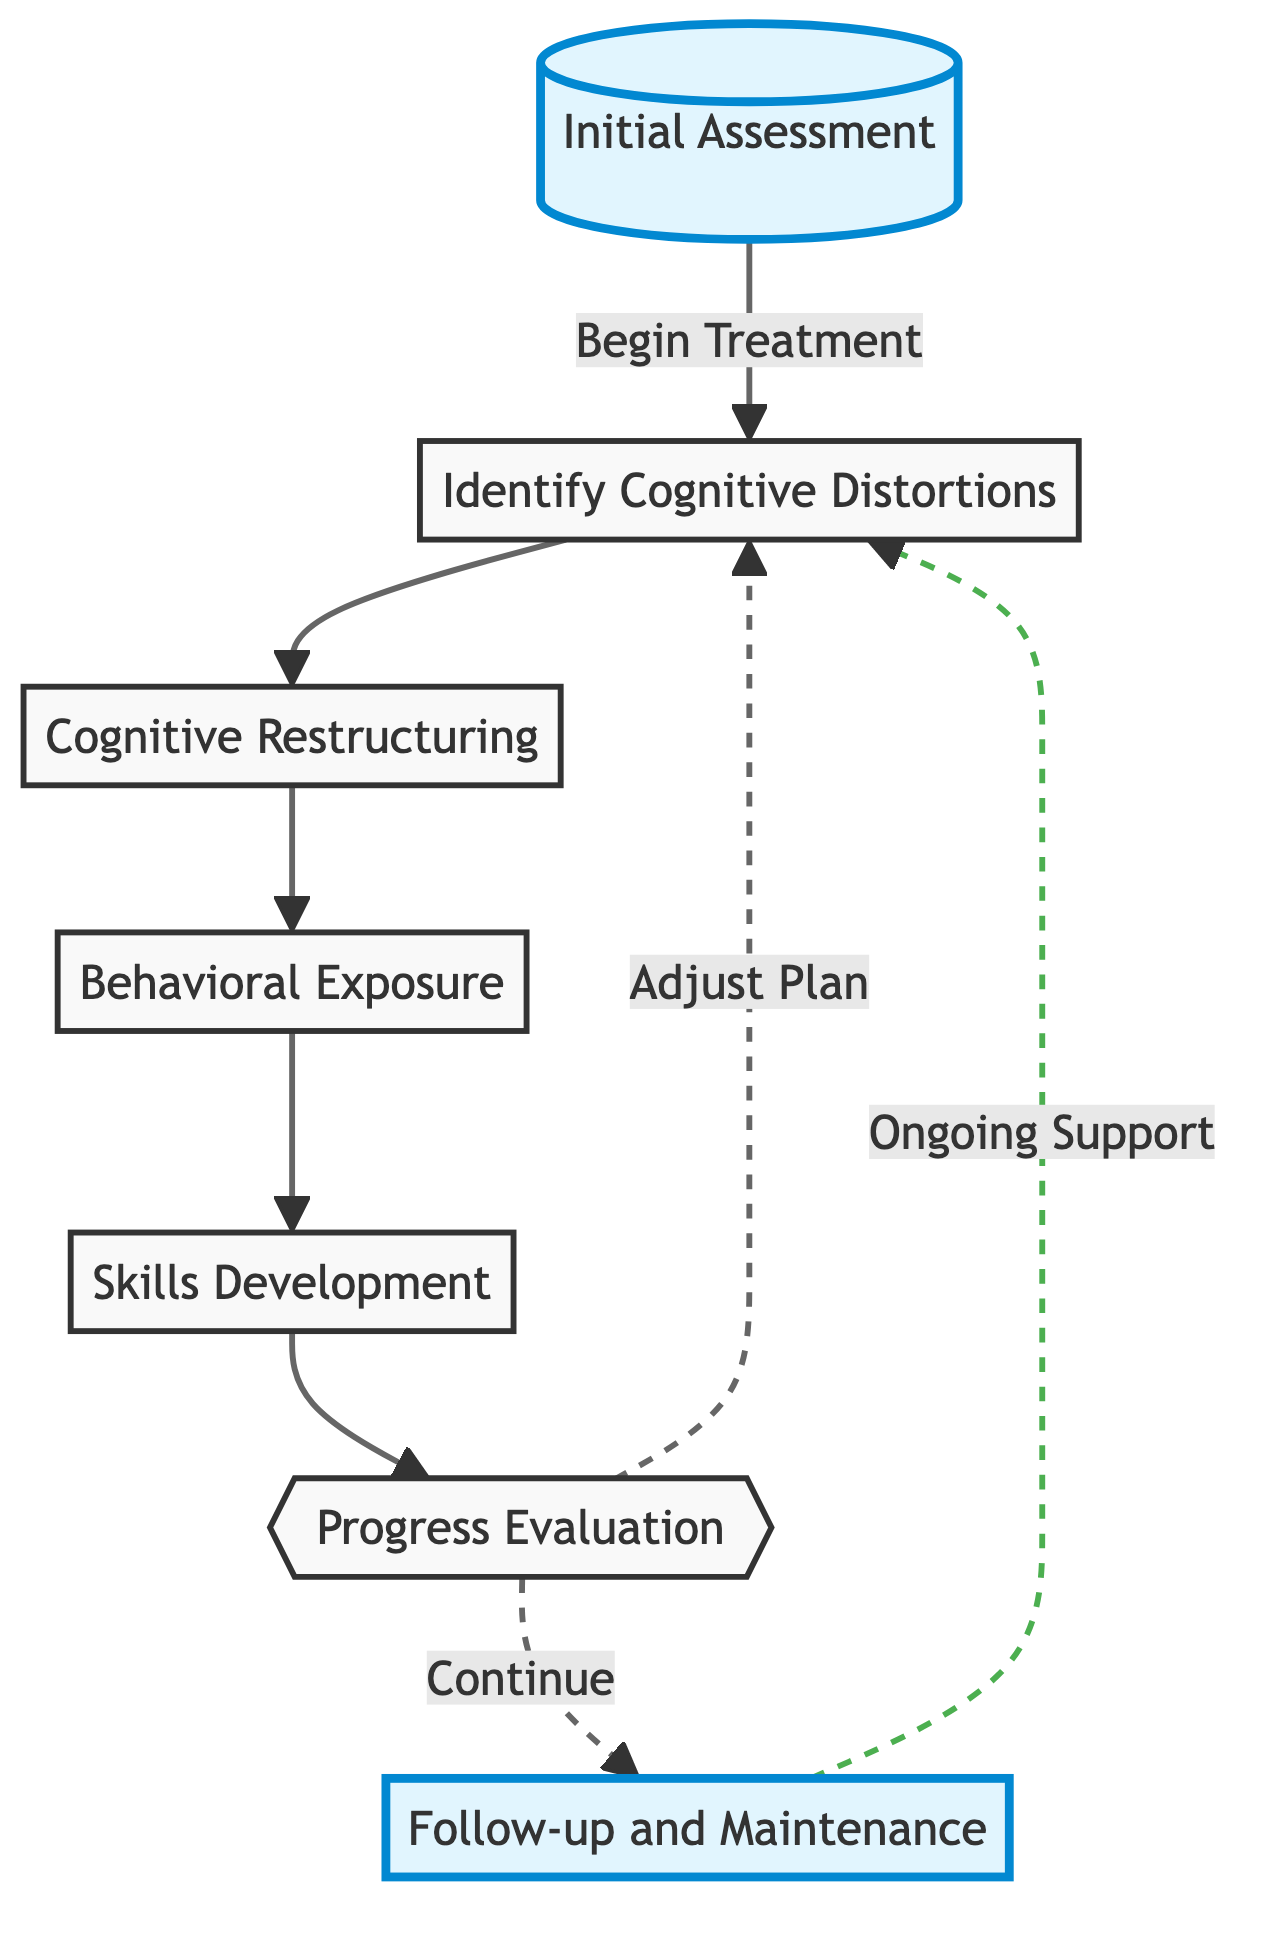What is the first step in the workflow? The first step in the workflow is titled "Initial Assessment," which is indicated as the starting point in the diagram.
Answer: Initial Assessment How many main nodes are present in the flowchart? By counting all the distinct steps represented by the nodes, we find there are a total of seven main nodes in the diagram.
Answer: 7 What connects "Cognitive Restructuring" and "Behavioral Exposure"? The connection between "Cognitive Restructuring" and "Behavioral Exposure" is represented by a direct arrow, indicating a sequential relationship where one step follows the other.
Answer: Arrow What is the subsequent step after "Progress Evaluation" if the plan is adjusted? According to the diagram, if the treatment plan is adjusted after "Progress Evaluation," the next step would lead back to "Identify Cognitive Distortions."
Answer: Identify Cognitive Distortions What does the dashed line from "Follow-up and Maintenance" indicate? The dashed line from "Follow-up and Maintenance" signifies ongoing support that continues to loop back to "Identify Cognitive Distortions," indicating a non-linear relationship in the workflow for continuous care.
Answer: Ongoing Support Which step follows "Skills Development"? The diagram shows that the step that follows "Skills Development" is "Progress Evaluation," as indicated by the direct arrow connecting these two nodes.
Answer: Progress Evaluation What is the relationship between "Initial Assessment" and "Follow-up and Maintenance"? Both nodes are highlighted, but they don't have a direct connection in the flowchart; "Initial Assessment" is the start, while "Follow-up and Maintenance" comes later, indicating progression in treatment.
Answer: No direct connection What type of techniques are introduced during "Skills Development"? The techniques introduced during "Skills Development" are coping strategies, including relaxation techniques and problem-solving skills, as stated in the description associated with that node.
Answer: Coping Strategies 